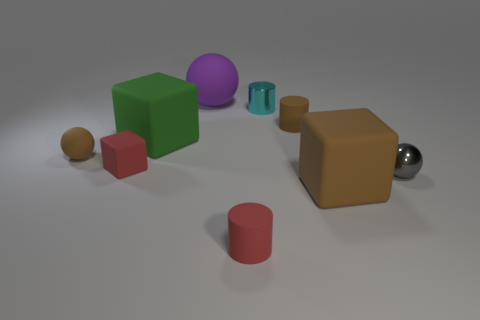Add 1 small cylinders. How many objects exist? 10 Subtract all cylinders. How many objects are left? 6 Subtract 0 blue balls. How many objects are left? 9 Subtract all small yellow spheres. Subtract all big purple spheres. How many objects are left? 8 Add 5 brown blocks. How many brown blocks are left? 6 Add 9 cyan objects. How many cyan objects exist? 10 